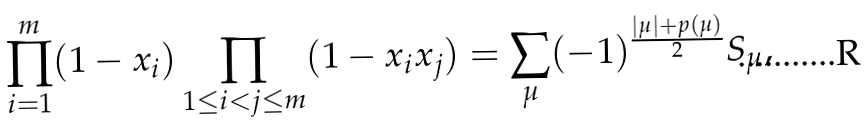Convert formula to latex. <formula><loc_0><loc_0><loc_500><loc_500>\prod _ { i = 1 } ^ { m } ( 1 - x _ { i } ) \prod _ { 1 \leq i < j \leq m } ( 1 - x _ { i } x _ { j } ) = \sum _ { \mu } ( - 1 ) ^ { \frac { | \mu | + p ( \mu ) } { 2 } } S _ { \mu } ,</formula> 